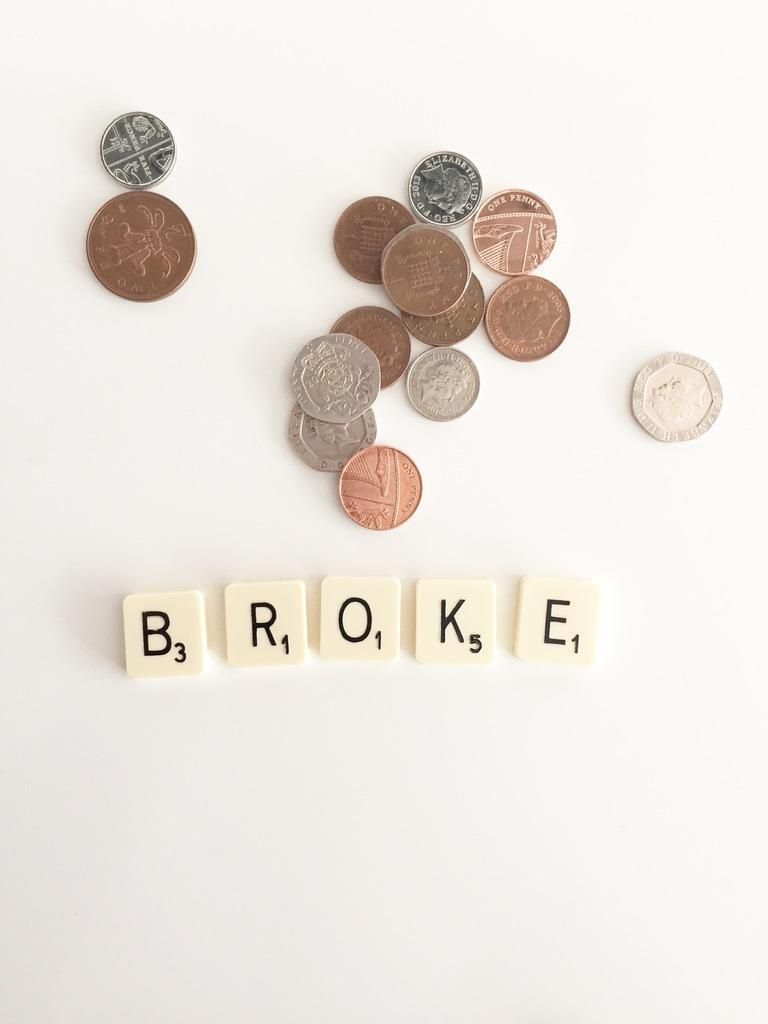What colors of coins can be seen in the image? There are white, silver, copper, and brown color coins in the image. How are the coins arranged in the image? The coins are arranged on a surface. What color is the background of the image? The background of the image is white. How much wood is present in the image? There is no wood present in the image; it features coins arranged on a surface with a white background. 